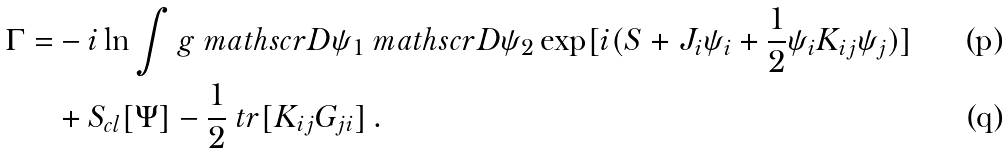Convert formula to latex. <formula><loc_0><loc_0><loc_500><loc_500>\Gamma = & - i \ln \int g \ m a t h s c r { D } \psi _ { 1 } \ m a t h s c r { D } \psi _ { 2 } \exp [ i ( S + J _ { i } \psi _ { i } + { \frac { 1 } { 2 } } \psi _ { i } K _ { i j } \psi _ { j } ) ] \\ & + S _ { c l } [ \Psi ] - { \frac { 1 } { 2 } } \ t r [ K _ { i j } G _ { j i } ] \, .</formula> 